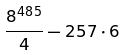<formula> <loc_0><loc_0><loc_500><loc_500>\frac { 8 ^ { 4 8 5 } } { 4 } - 2 5 7 \cdot 6</formula> 